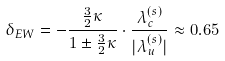Convert formula to latex. <formula><loc_0><loc_0><loc_500><loc_500>\delta _ { E W } = - \frac { \frac { 3 } { 2 } \kappa } { 1 \pm \frac { 3 } { 2 } \kappa } \cdot \frac { \lambda ^ { ( s ) } _ { c } } { | \lambda ^ { ( s ) } _ { u } | } \approx 0 . 6 5</formula> 